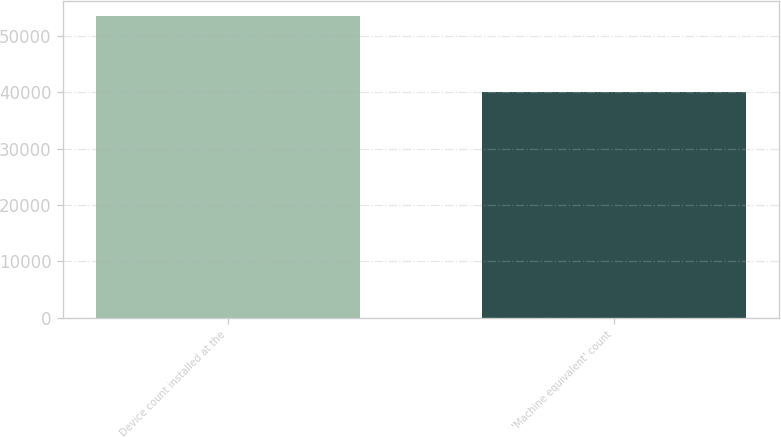Convert chart. <chart><loc_0><loc_0><loc_500><loc_500><bar_chart><fcel>Device count installed at the<fcel>'Machine equivalent' count<nl><fcel>53547<fcel>40067<nl></chart> 